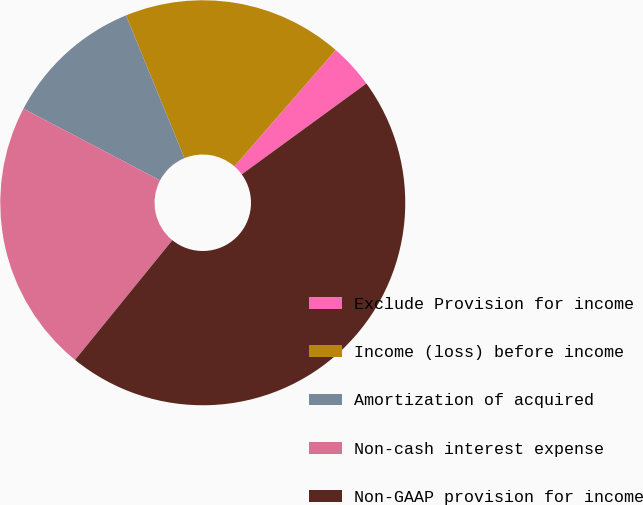Convert chart to OTSL. <chart><loc_0><loc_0><loc_500><loc_500><pie_chart><fcel>Exclude Provision for income<fcel>Income (loss) before income<fcel>Amortization of acquired<fcel>Non-cash interest expense<fcel>Non-GAAP provision for income<nl><fcel>3.58%<fcel>17.59%<fcel>11.12%<fcel>21.83%<fcel>45.89%<nl></chart> 